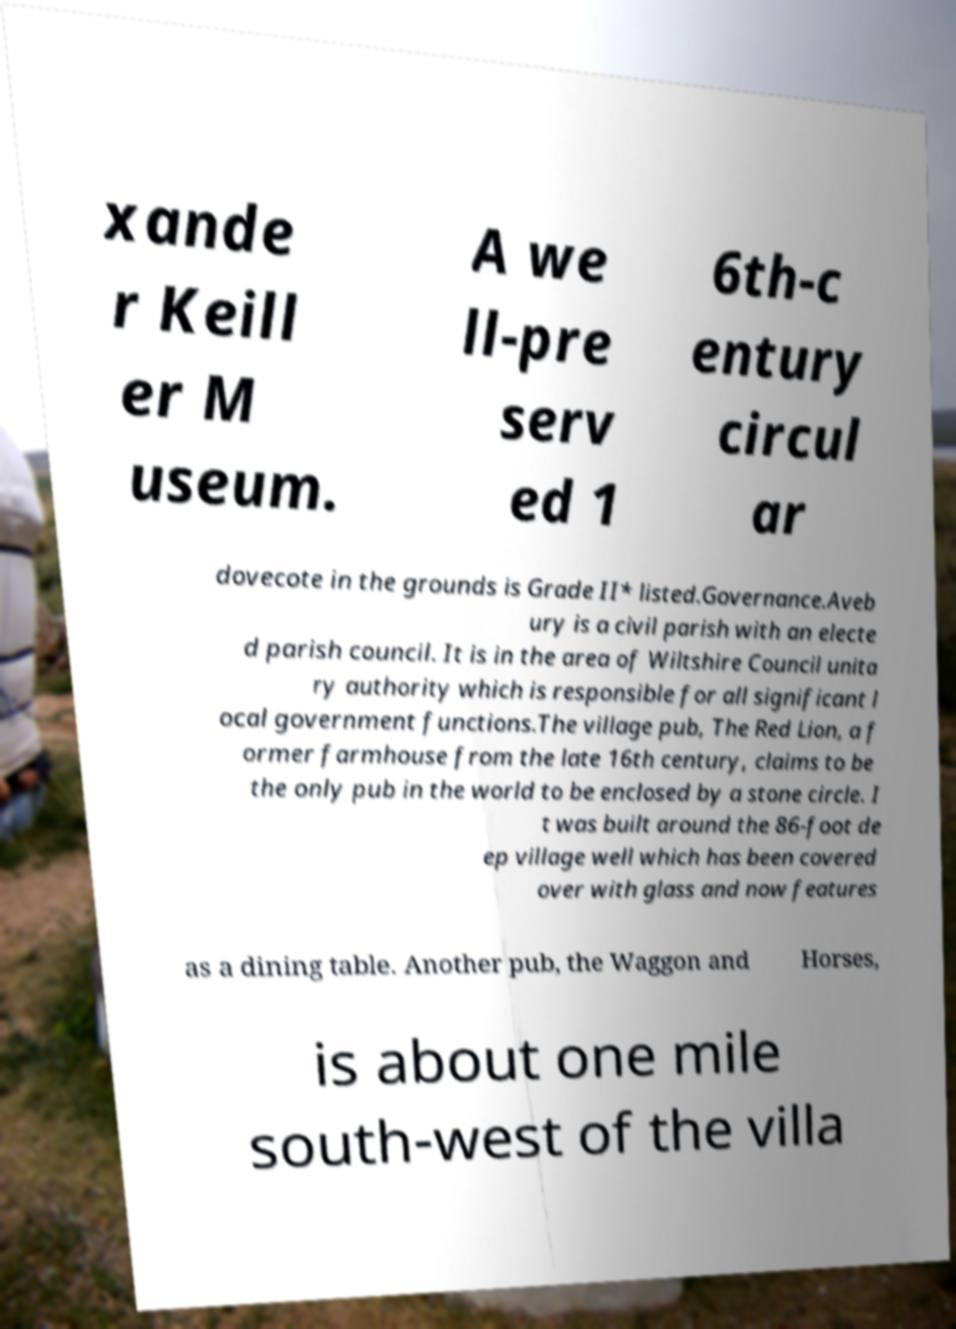Can you accurately transcribe the text from the provided image for me? xande r Keill er M useum. A we ll-pre serv ed 1 6th-c entury circul ar dovecote in the grounds is Grade II* listed.Governance.Aveb ury is a civil parish with an electe d parish council. It is in the area of Wiltshire Council unita ry authority which is responsible for all significant l ocal government functions.The village pub, The Red Lion, a f ormer farmhouse from the late 16th century, claims to be the only pub in the world to be enclosed by a stone circle. I t was built around the 86-foot de ep village well which has been covered over with glass and now features as a dining table. Another pub, the Waggon and Horses, is about one mile south-west of the villa 